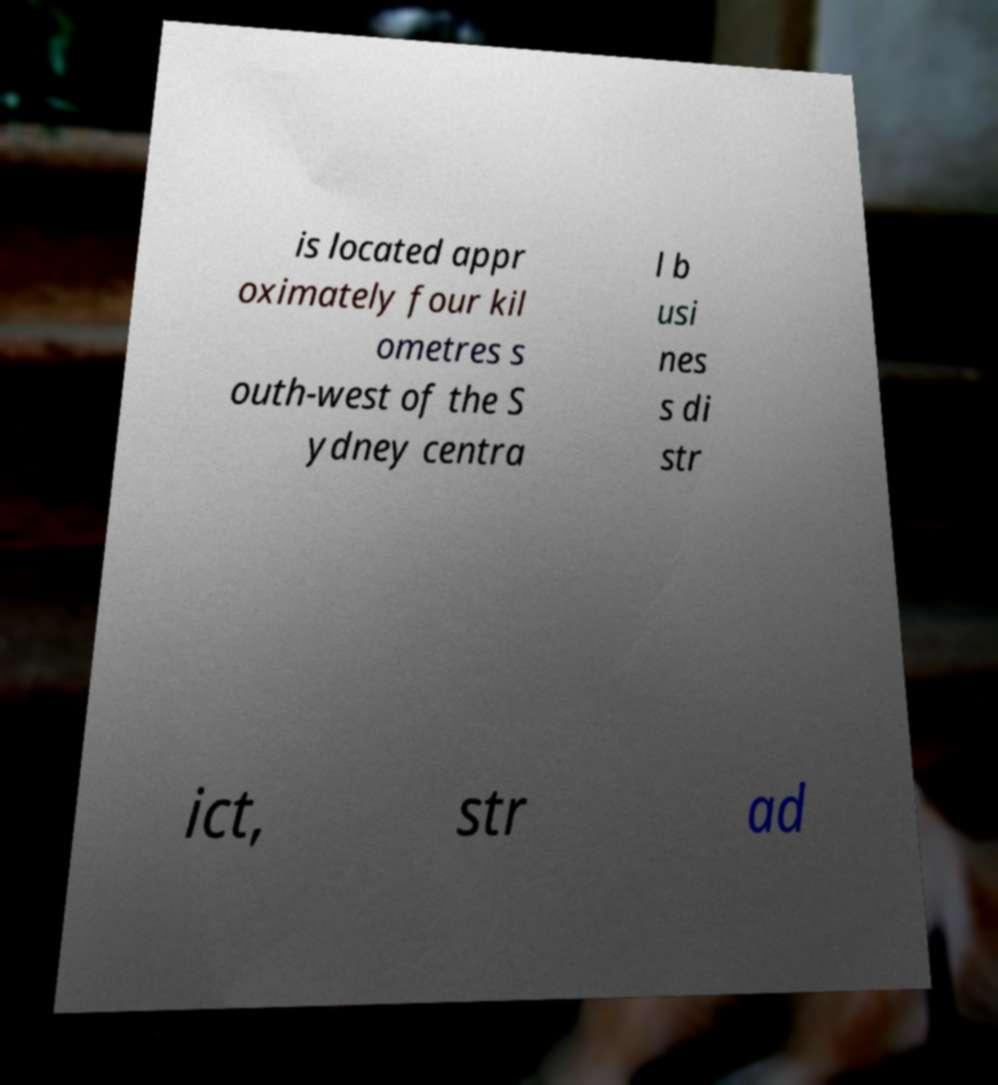For documentation purposes, I need the text within this image transcribed. Could you provide that? is located appr oximately four kil ometres s outh-west of the S ydney centra l b usi nes s di str ict, str ad 